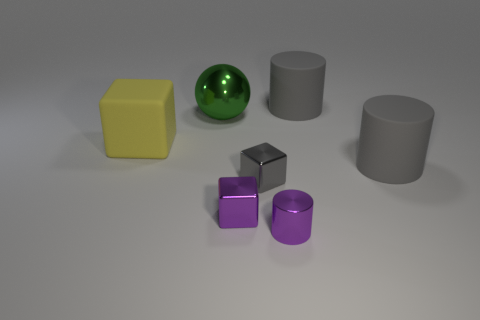Subtract all large gray cylinders. How many cylinders are left? 1 Add 2 gray blocks. How many objects exist? 9 Subtract all gray cylinders. How many cylinders are left? 1 Subtract all blue blocks. How many yellow cylinders are left? 0 Subtract all matte blocks. Subtract all tiny gray objects. How many objects are left? 5 Add 5 big things. How many big things are left? 9 Add 6 small matte blocks. How many small matte blocks exist? 6 Subtract 0 blue cylinders. How many objects are left? 7 Subtract all blocks. How many objects are left? 4 Subtract 1 spheres. How many spheres are left? 0 